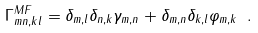<formula> <loc_0><loc_0><loc_500><loc_500>\Gamma ^ { M F } _ { m n , k l } = \delta _ { m , l } \delta _ { n , k } \gamma _ { m , n } + \delta _ { m , n } \delta _ { k , l } \varphi _ { m , k } \ .</formula> 